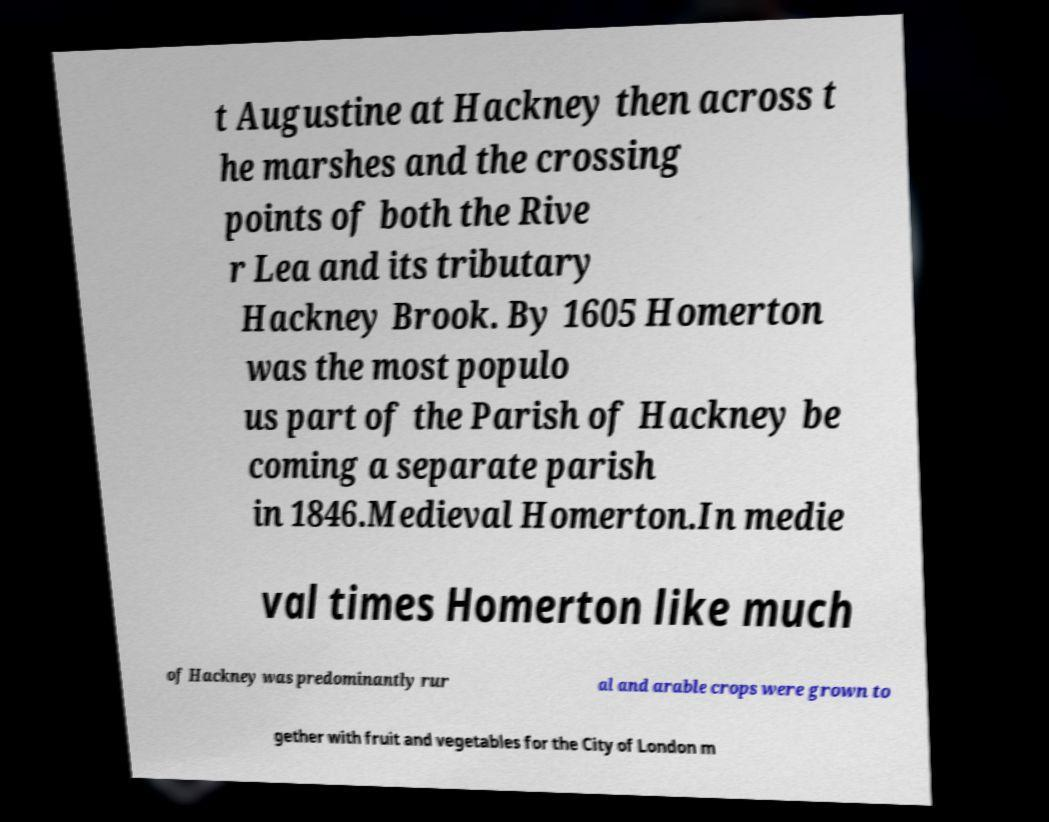There's text embedded in this image that I need extracted. Can you transcribe it verbatim? t Augustine at Hackney then across t he marshes and the crossing points of both the Rive r Lea and its tributary Hackney Brook. By 1605 Homerton was the most populo us part of the Parish of Hackney be coming a separate parish in 1846.Medieval Homerton.In medie val times Homerton like much of Hackney was predominantly rur al and arable crops were grown to gether with fruit and vegetables for the City of London m 